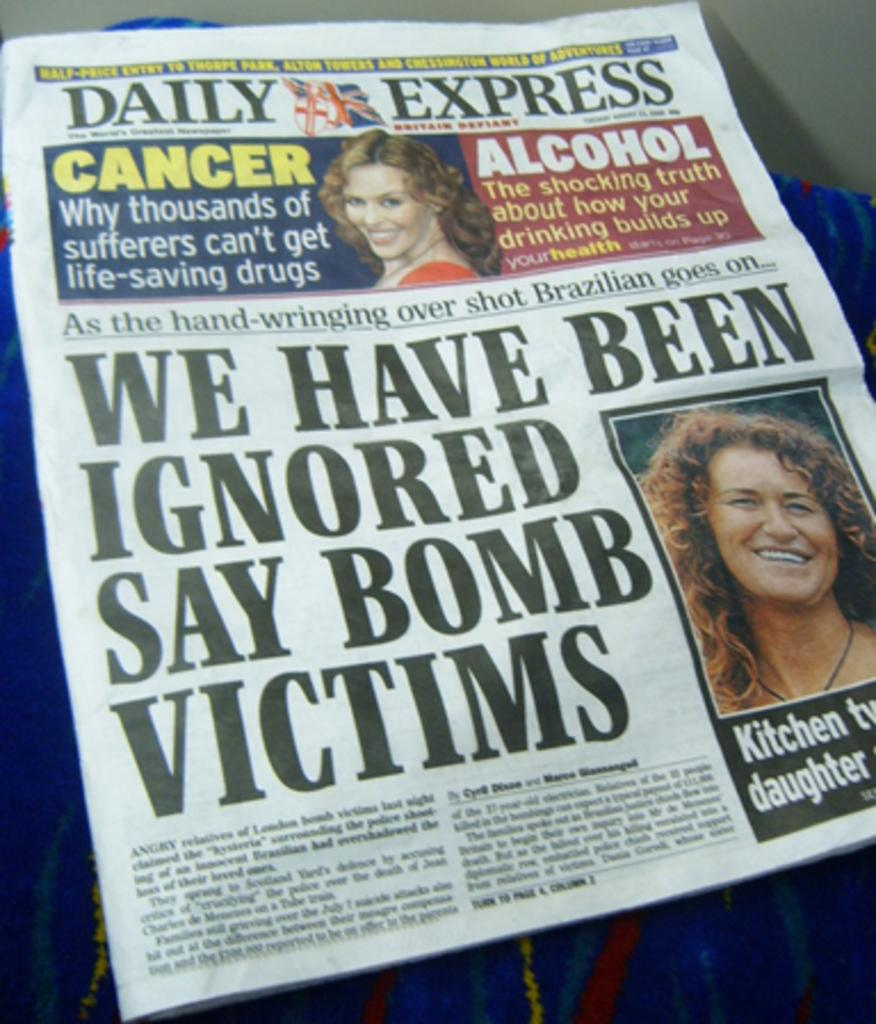What is the main object in the image? There is a newspaper in the image. What can be seen on the newspaper? There are two women's photos on the newspaper. What else is present on the newspaper besides the photos? There is text present on the newspaper. How many frogs can be seen jumping out of the hole in the newspaper? There are no frogs or holes present in the image; it features a newspaper with two women's photos and text. What type of horn is visible on the newspaper? There is no horn present in the image; it features a newspaper with two women's photos and text. 